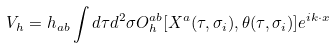Convert formula to latex. <formula><loc_0><loc_0><loc_500><loc_500>V _ { h } = h _ { a b } \int d \tau d ^ { 2 } \sigma O _ { h } ^ { a b } [ X ^ { a } ( \tau , \sigma _ { i } ) , \theta ( \tau , \sigma _ { i } ) ] e ^ { i k \cdot x }</formula> 